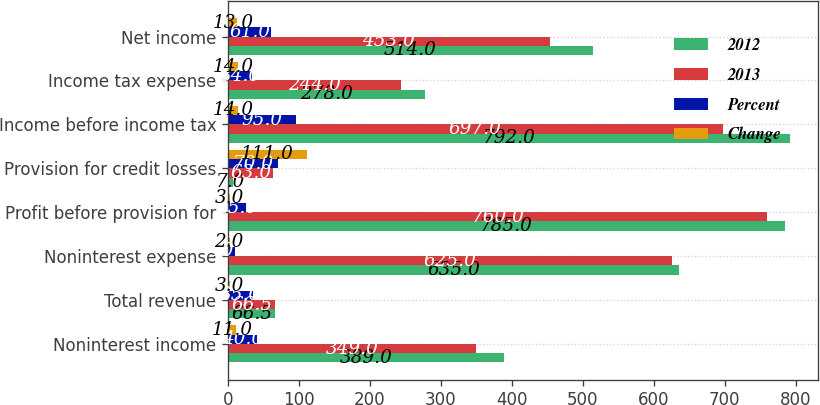Convert chart to OTSL. <chart><loc_0><loc_0><loc_500><loc_500><stacked_bar_chart><ecel><fcel>Noninterest income<fcel>Total revenue<fcel>Noninterest expense<fcel>Profit before provision for<fcel>Provision for credit losses<fcel>Income before income tax<fcel>Income tax expense<fcel>Net income<nl><fcel>2012<fcel>389<fcel>66.5<fcel>635<fcel>785<fcel>7<fcel>792<fcel>278<fcel>514<nl><fcel>2013<fcel>349<fcel>66.5<fcel>625<fcel>760<fcel>63<fcel>697<fcel>244<fcel>453<nl><fcel>Percent<fcel>40<fcel>35<fcel>10<fcel>25<fcel>70<fcel>95<fcel>34<fcel>61<nl><fcel>Change<fcel>11<fcel>3<fcel>2<fcel>3<fcel>111<fcel>14<fcel>14<fcel>13<nl></chart> 